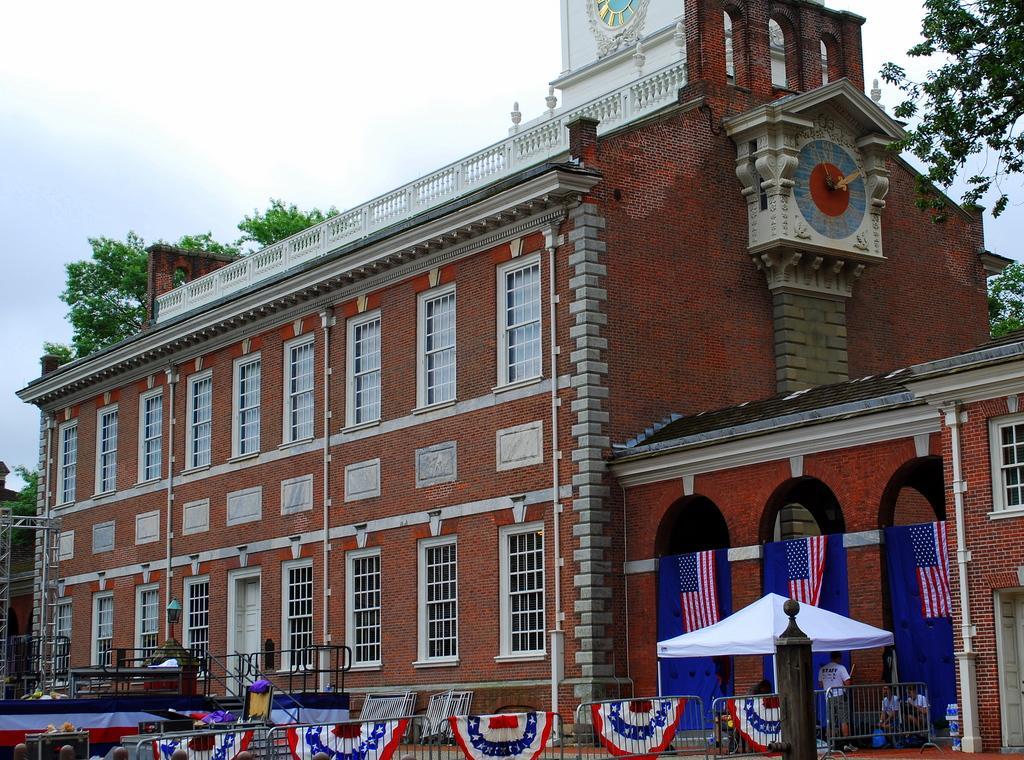Could you give a brief overview of what you see in this image? In this image I can see a building and in the front of it I can see few flags, railings and few people. I can also see few trees on the both sides of the image and in the background I can see the sky. On the right side of the image I can see a clock on the building's wall. 